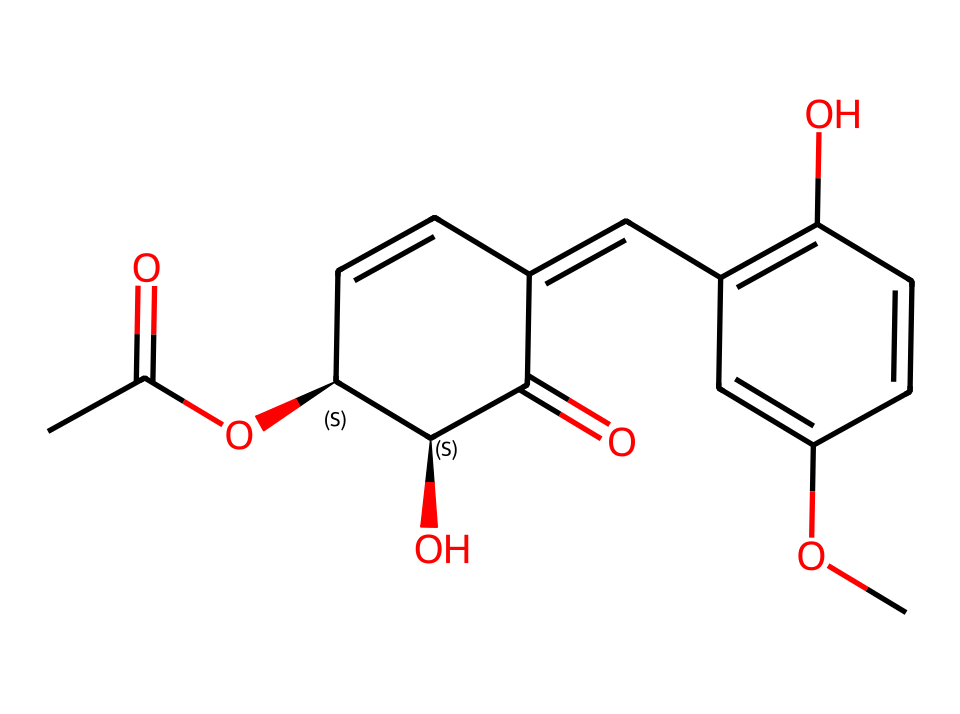How many oxygen atoms are in this chemical? By examining the structure, we can count the number of oxygen atoms. The SMILES representation shows five instances of 'O', indicating five oxygen atoms present in the molecule.
Answer: five What is the molecular weight of this chemical? To find the molecular weight, we would typically need to sum the atomic weights of all the individual atoms represented in the SMILES string. Considering the atoms (carbon, hydrogen, and oxygen), the molecular weight is calculated to be approximately 322.34 g/mol.
Answer: approximately 322.34 g/mol Does this compound have any rings in its structure? By analyzing the SMILES, we can identify numbers indicating ring formations (like '1' and '2'). The presence of these numbers indicates that the chemical has a cyclical structure, confirming that it contains rings.
Answer: yes What functional groups are present in this chemical? A detailed look at the SMILES shows various functional groups. The presence of '=' indicates double bonds, and 'O' indicates hydroxyl and carbonyl functionalities, revealing the chemical features such as ethers and ketones.
Answer: carbonyl, hydroxyl, ether What is the role of the hydroxyl group in this chemical? The hydroxyl group (-OH) generally plays a significant role in the solubility and reactivity of the compound. It can engage in hydrogen bonding, which may increase the compound's antibacterial efficacy by interacting with bacterial cell membranes.
Answer: solubility and reactivity Is this compound likely to be hydrophilic or hydrophobic? Considering the presence of multiple oxygen atoms and hydroxyl groups, the compound is likely to be more hydrophilic due to the ability of these groups to form hydrogen bonds with water.
Answer: hydrophilic 